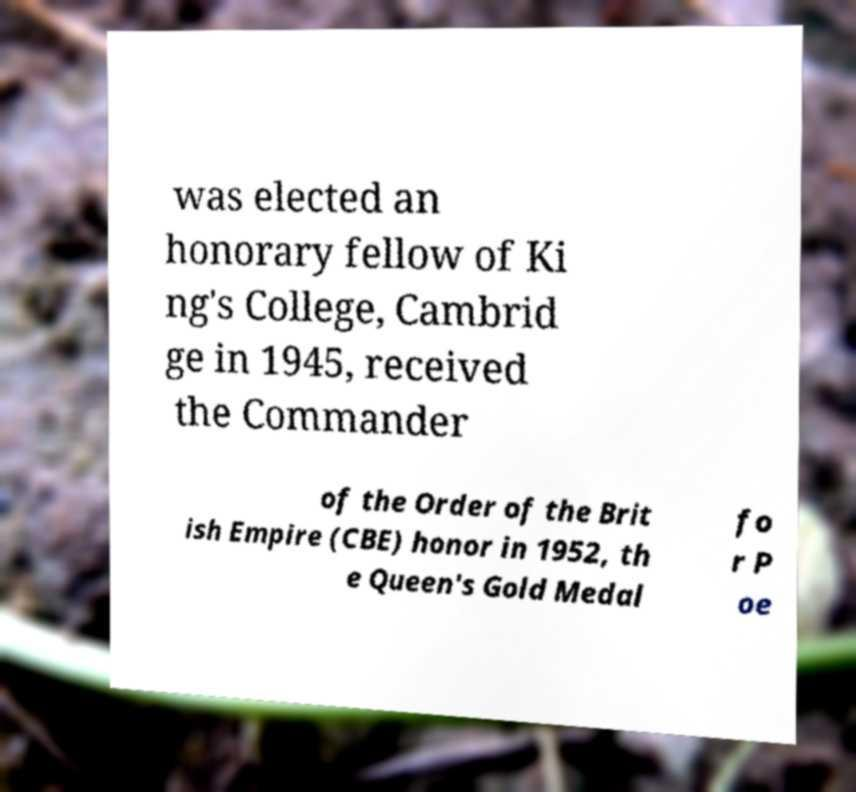Please identify and transcribe the text found in this image. was elected an honorary fellow of Ki ng's College, Cambrid ge in 1945, received the Commander of the Order of the Brit ish Empire (CBE) honor in 1952, th e Queen's Gold Medal fo r P oe 